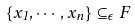Convert formula to latex. <formula><loc_0><loc_0><loc_500><loc_500>\left \{ x _ { 1 } , \cdots , x _ { n } \right \} \subseteq _ { \epsilon } F</formula> 